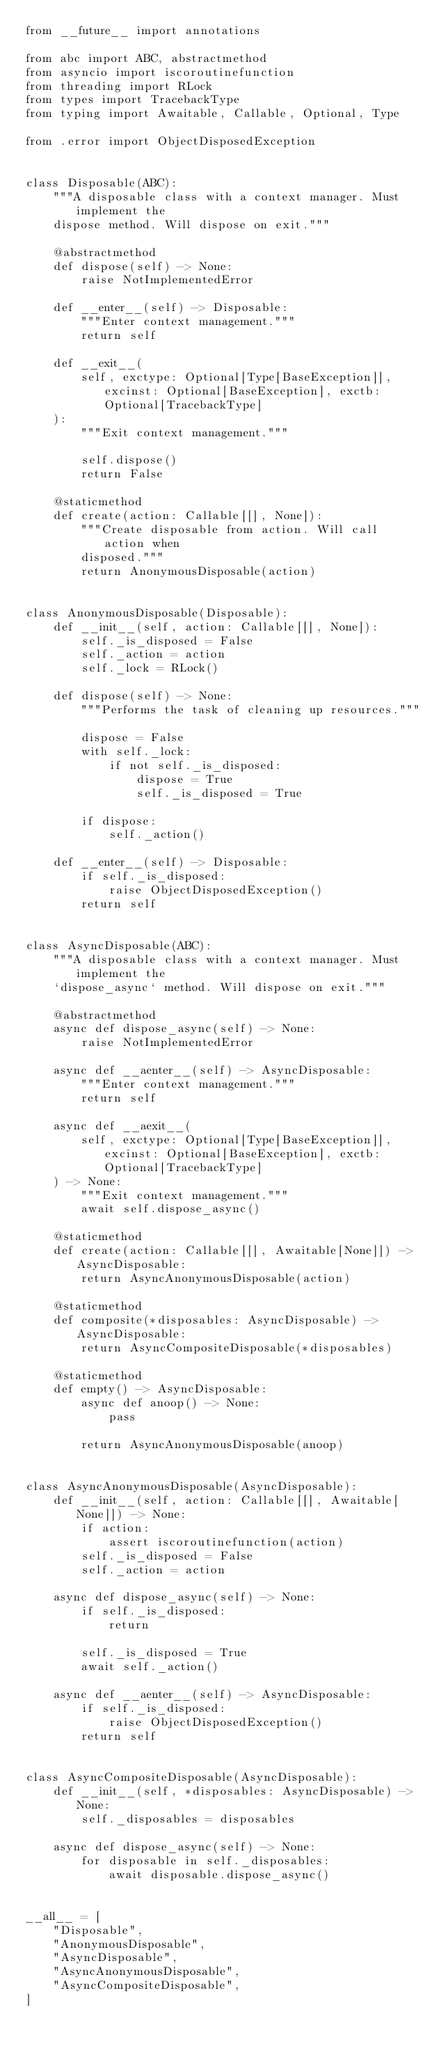Convert code to text. <code><loc_0><loc_0><loc_500><loc_500><_Python_>from __future__ import annotations

from abc import ABC, abstractmethod
from asyncio import iscoroutinefunction
from threading import RLock
from types import TracebackType
from typing import Awaitable, Callable, Optional, Type

from .error import ObjectDisposedException


class Disposable(ABC):
    """A disposable class with a context manager. Must implement the
    dispose method. Will dispose on exit."""

    @abstractmethod
    def dispose(self) -> None:
        raise NotImplementedError

    def __enter__(self) -> Disposable:
        """Enter context management."""
        return self

    def __exit__(
        self, exctype: Optional[Type[BaseException]], excinst: Optional[BaseException], exctb: Optional[TracebackType]
    ):
        """Exit context management."""

        self.dispose()
        return False

    @staticmethod
    def create(action: Callable[[], None]):
        """Create disposable from action. Will call action when
        disposed."""
        return AnonymousDisposable(action)


class AnonymousDisposable(Disposable):
    def __init__(self, action: Callable[[], None]):
        self._is_disposed = False
        self._action = action
        self._lock = RLock()

    def dispose(self) -> None:
        """Performs the task of cleaning up resources."""

        dispose = False
        with self._lock:
            if not self._is_disposed:
                dispose = True
                self._is_disposed = True

        if dispose:
            self._action()

    def __enter__(self) -> Disposable:
        if self._is_disposed:
            raise ObjectDisposedException()
        return self


class AsyncDisposable(ABC):
    """A disposable class with a context manager. Must implement the
    `dispose_async` method. Will dispose on exit."""

    @abstractmethod
    async def dispose_async(self) -> None:
        raise NotImplementedError

    async def __aenter__(self) -> AsyncDisposable:
        """Enter context management."""
        return self

    async def __aexit__(
        self, exctype: Optional[Type[BaseException]], excinst: Optional[BaseException], exctb: Optional[TracebackType]
    ) -> None:
        """Exit context management."""
        await self.dispose_async()

    @staticmethod
    def create(action: Callable[[], Awaitable[None]]) -> AsyncDisposable:
        return AsyncAnonymousDisposable(action)

    @staticmethod
    def composite(*disposables: AsyncDisposable) -> AsyncDisposable:
        return AsyncCompositeDisposable(*disposables)

    @staticmethod
    def empty() -> AsyncDisposable:
        async def anoop() -> None:
            pass

        return AsyncAnonymousDisposable(anoop)


class AsyncAnonymousDisposable(AsyncDisposable):
    def __init__(self, action: Callable[[], Awaitable[None]]) -> None:
        if action:
            assert iscoroutinefunction(action)
        self._is_disposed = False
        self._action = action

    async def dispose_async(self) -> None:
        if self._is_disposed:
            return

        self._is_disposed = True
        await self._action()

    async def __aenter__(self) -> AsyncDisposable:
        if self._is_disposed:
            raise ObjectDisposedException()
        return self


class AsyncCompositeDisposable(AsyncDisposable):
    def __init__(self, *disposables: AsyncDisposable) -> None:
        self._disposables = disposables

    async def dispose_async(self) -> None:
        for disposable in self._disposables:
            await disposable.dispose_async()


__all__ = [
    "Disposable",
    "AnonymousDisposable",
    "AsyncDisposable",
    "AsyncAnonymousDisposable",
    "AsyncCompositeDisposable",
]
</code> 